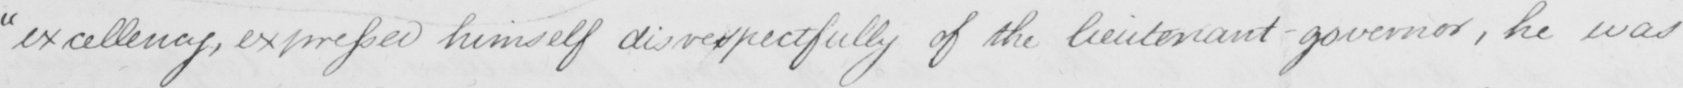Transcribe the text shown in this historical manuscript line. " excellency , expressed himself disrespectfully of the lieutenant-governor , he was 